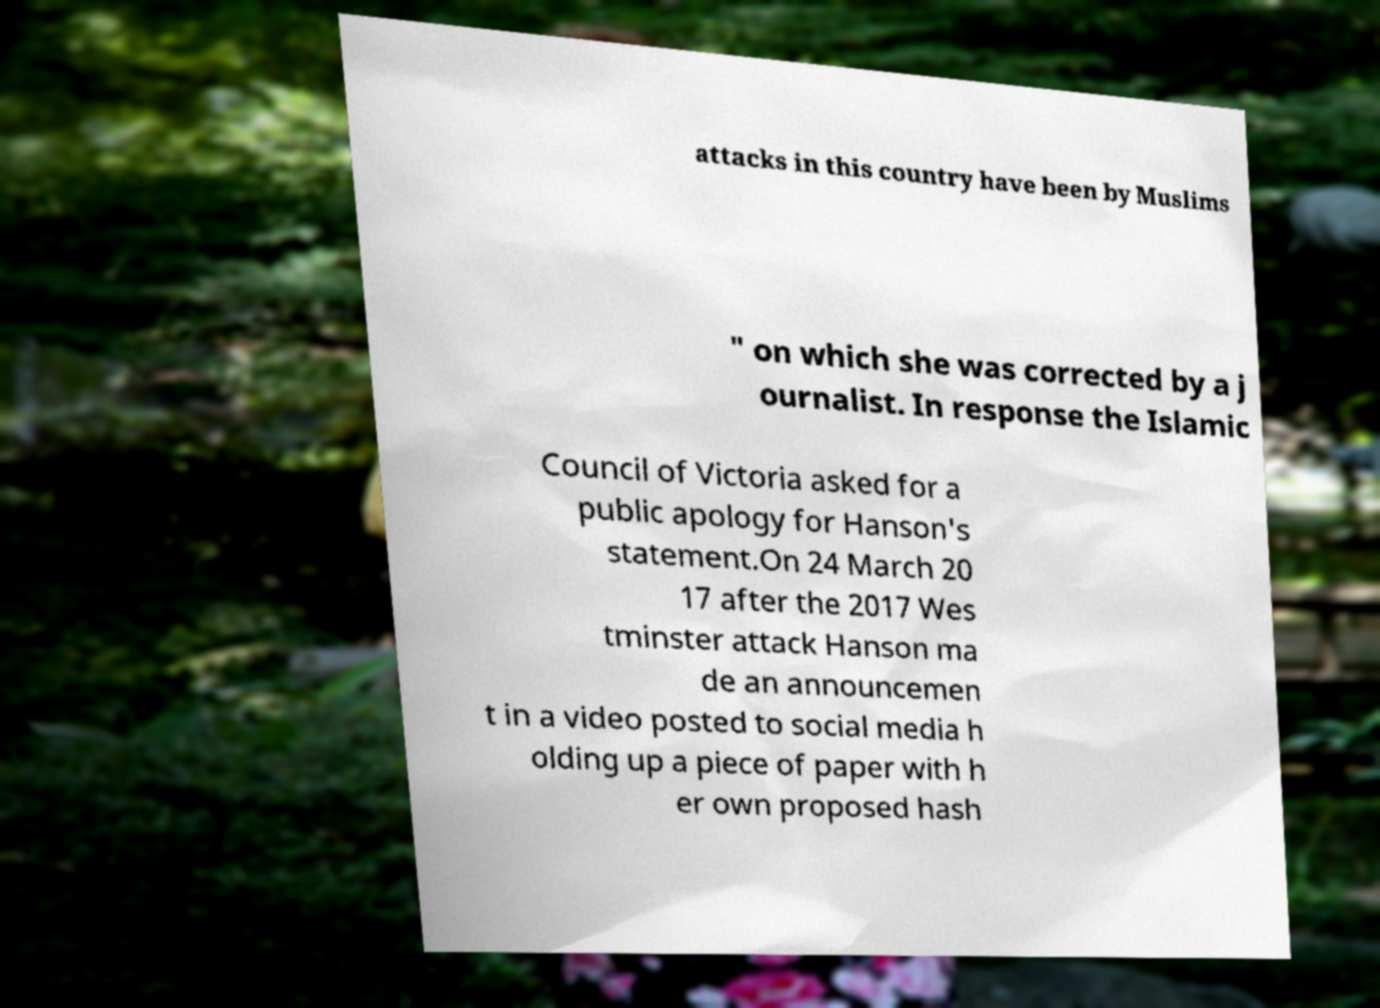I need the written content from this picture converted into text. Can you do that? attacks in this country have been by Muslims " on which she was corrected by a j ournalist. In response the Islamic Council of Victoria asked for a public apology for Hanson's statement.On 24 March 20 17 after the 2017 Wes tminster attack Hanson ma de an announcemen t in a video posted to social media h olding up a piece of paper with h er own proposed hash 